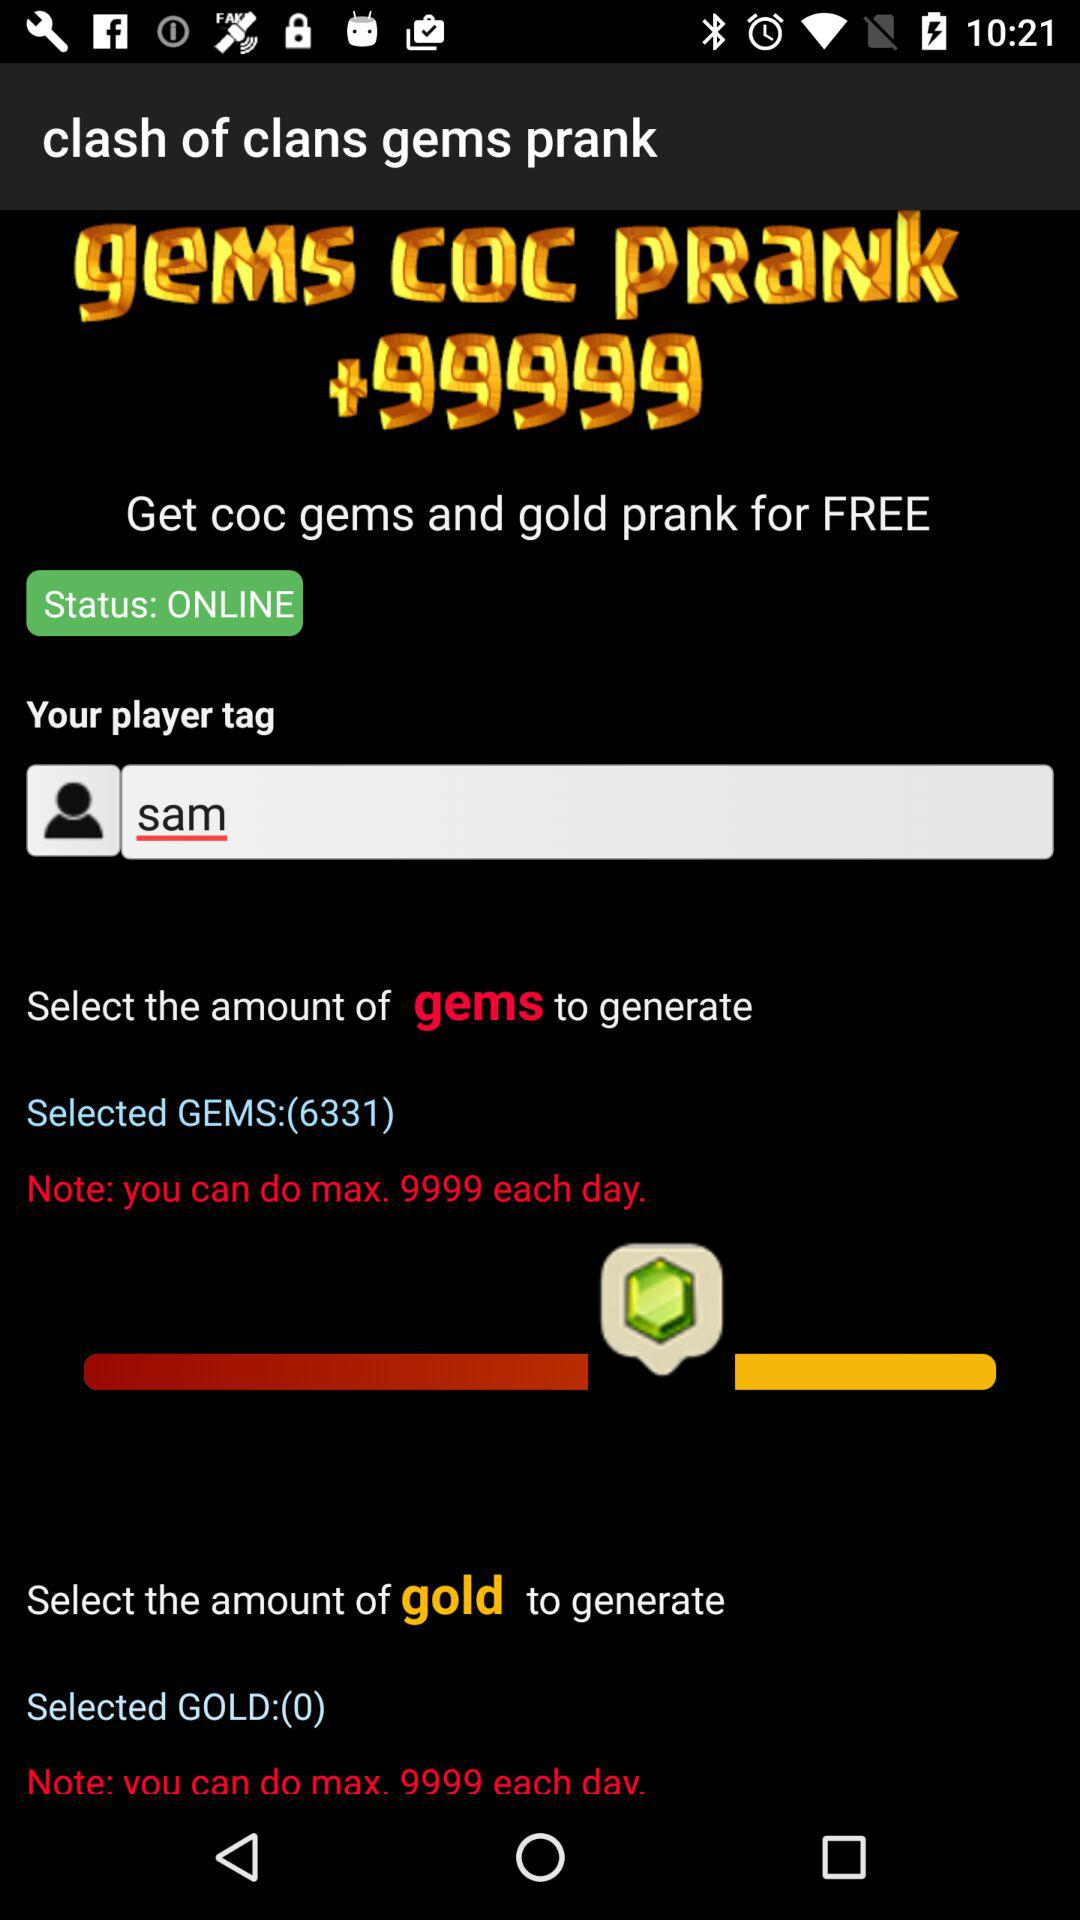What is the name of the player? The name of the player is Sam. 